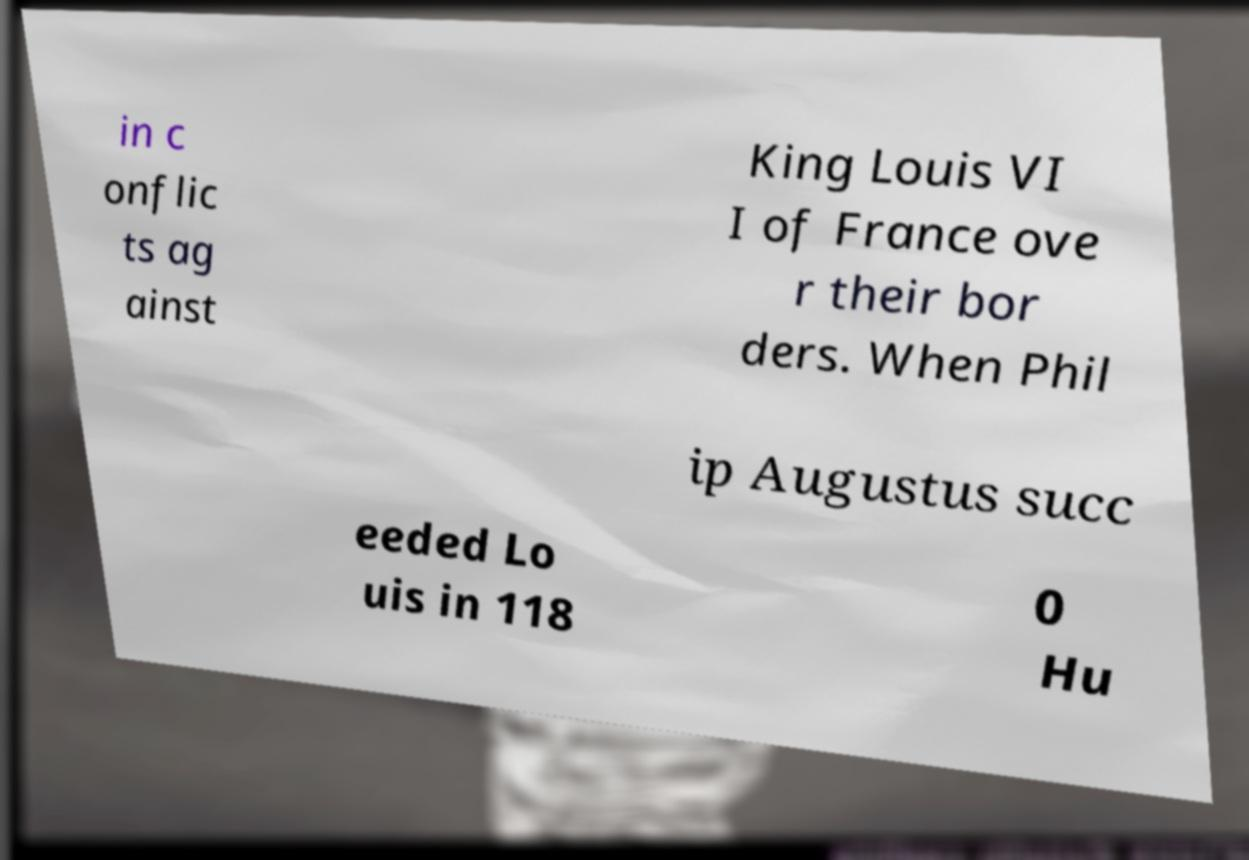Can you read and provide the text displayed in the image?This photo seems to have some interesting text. Can you extract and type it out for me? in c onflic ts ag ainst King Louis VI I of France ove r their bor ders. When Phil ip Augustus succ eeded Lo uis in 118 0 Hu 